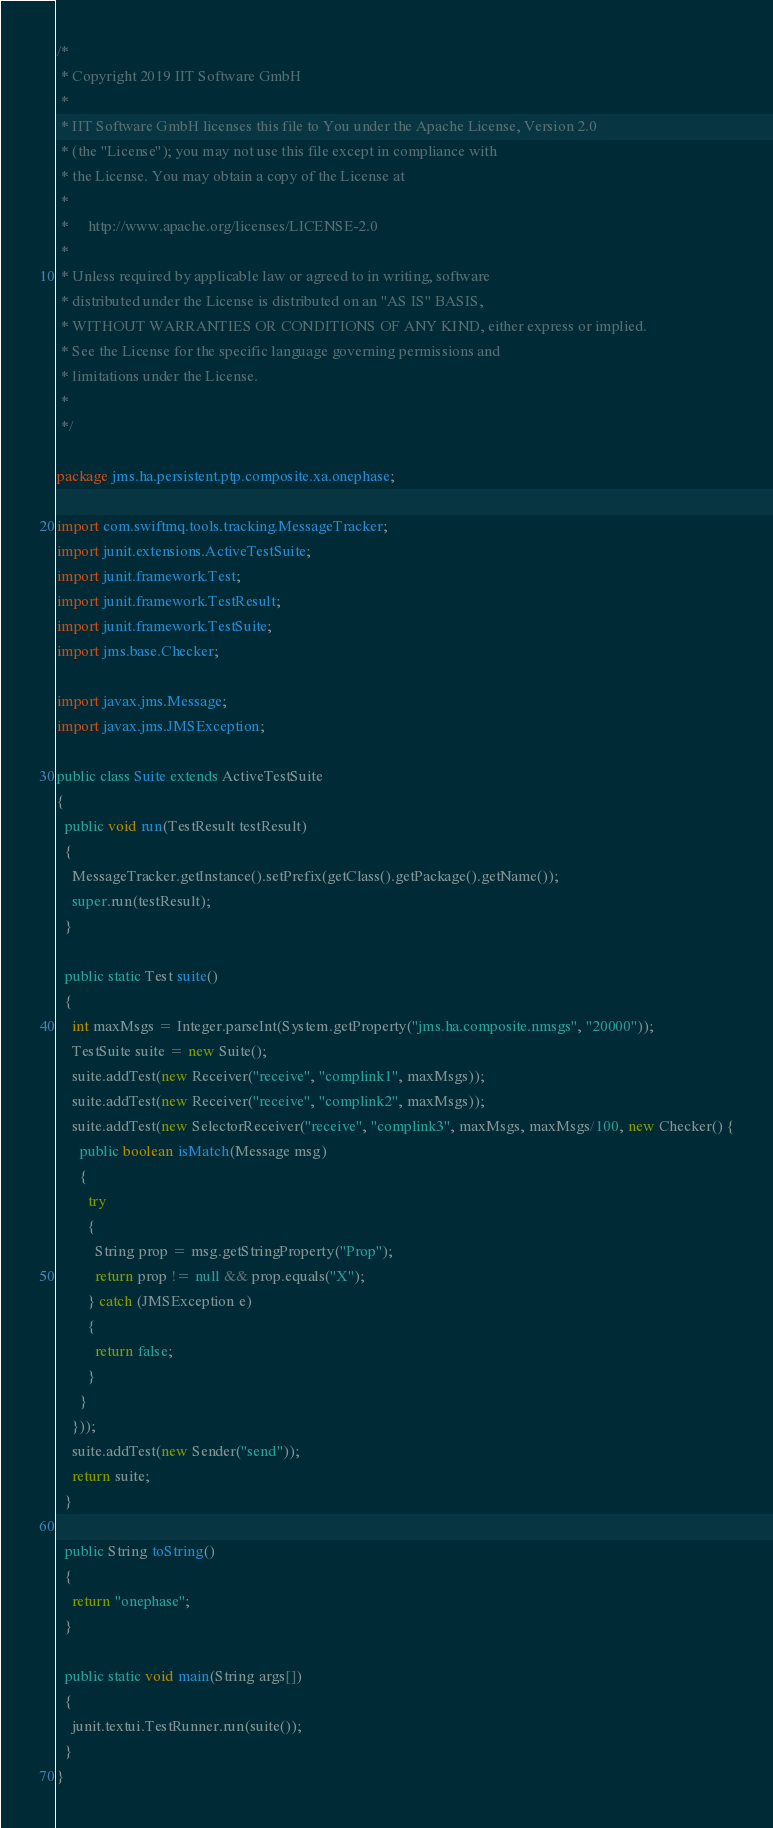<code> <loc_0><loc_0><loc_500><loc_500><_Java_>/*
 * Copyright 2019 IIT Software GmbH
 *
 * IIT Software GmbH licenses this file to You under the Apache License, Version 2.0
 * (the "License"); you may not use this file except in compliance with
 * the License. You may obtain a copy of the License at
 *
 *     http://www.apache.org/licenses/LICENSE-2.0
 *
 * Unless required by applicable law or agreed to in writing, software
 * distributed under the License is distributed on an "AS IS" BASIS,
 * WITHOUT WARRANTIES OR CONDITIONS OF ANY KIND, either express or implied.
 * See the License for the specific language governing permissions and
 * limitations under the License.
 *
 */

package jms.ha.persistent.ptp.composite.xa.onephase;

import com.swiftmq.tools.tracking.MessageTracker;
import junit.extensions.ActiveTestSuite;
import junit.framework.Test;
import junit.framework.TestResult;
import junit.framework.TestSuite;
import jms.base.Checker;

import javax.jms.Message;
import javax.jms.JMSException;

public class Suite extends ActiveTestSuite
{
  public void run(TestResult testResult)
  {
    MessageTracker.getInstance().setPrefix(getClass().getPackage().getName());
    super.run(testResult);
  }

  public static Test suite()
  {
    int maxMsgs = Integer.parseInt(System.getProperty("jms.ha.composite.nmsgs", "20000"));
    TestSuite suite = new Suite();
    suite.addTest(new Receiver("receive", "complink1", maxMsgs));
    suite.addTest(new Receiver("receive", "complink2", maxMsgs));
    suite.addTest(new SelectorReceiver("receive", "complink3", maxMsgs, maxMsgs/100, new Checker() {
      public boolean isMatch(Message msg)
      {
        try
        {
          String prop = msg.getStringProperty("Prop");
          return prop != null && prop.equals("X");
        } catch (JMSException e)
        {
          return false;
        }
      }
    }));
    suite.addTest(new Sender("send"));
    return suite;
  }

  public String toString()
  {
    return "onephase";
  }

  public static void main(String args[])
  {
    junit.textui.TestRunner.run(suite());
  }
}

</code> 